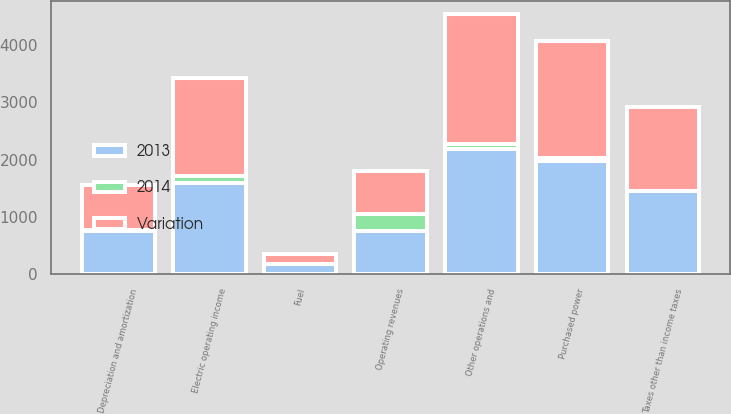Convert chart to OTSL. <chart><loc_0><loc_0><loc_500><loc_500><stacked_bar_chart><ecel><fcel>Operating revenues<fcel>Purchased power<fcel>Fuel<fcel>Other operations and<fcel>Depreciation and amortization<fcel>Taxes other than income taxes<fcel>Electric operating income<nl><fcel>Variation<fcel>749<fcel>2036<fcel>180<fcel>2270<fcel>781<fcel>1458<fcel>1712<nl><fcel>2013<fcel>749<fcel>1974<fcel>174<fcel>2180<fcel>749<fcel>1459<fcel>1595<nl><fcel>2014<fcel>306<fcel>62<fcel>6<fcel>90<fcel>32<fcel>1<fcel>117<nl></chart> 